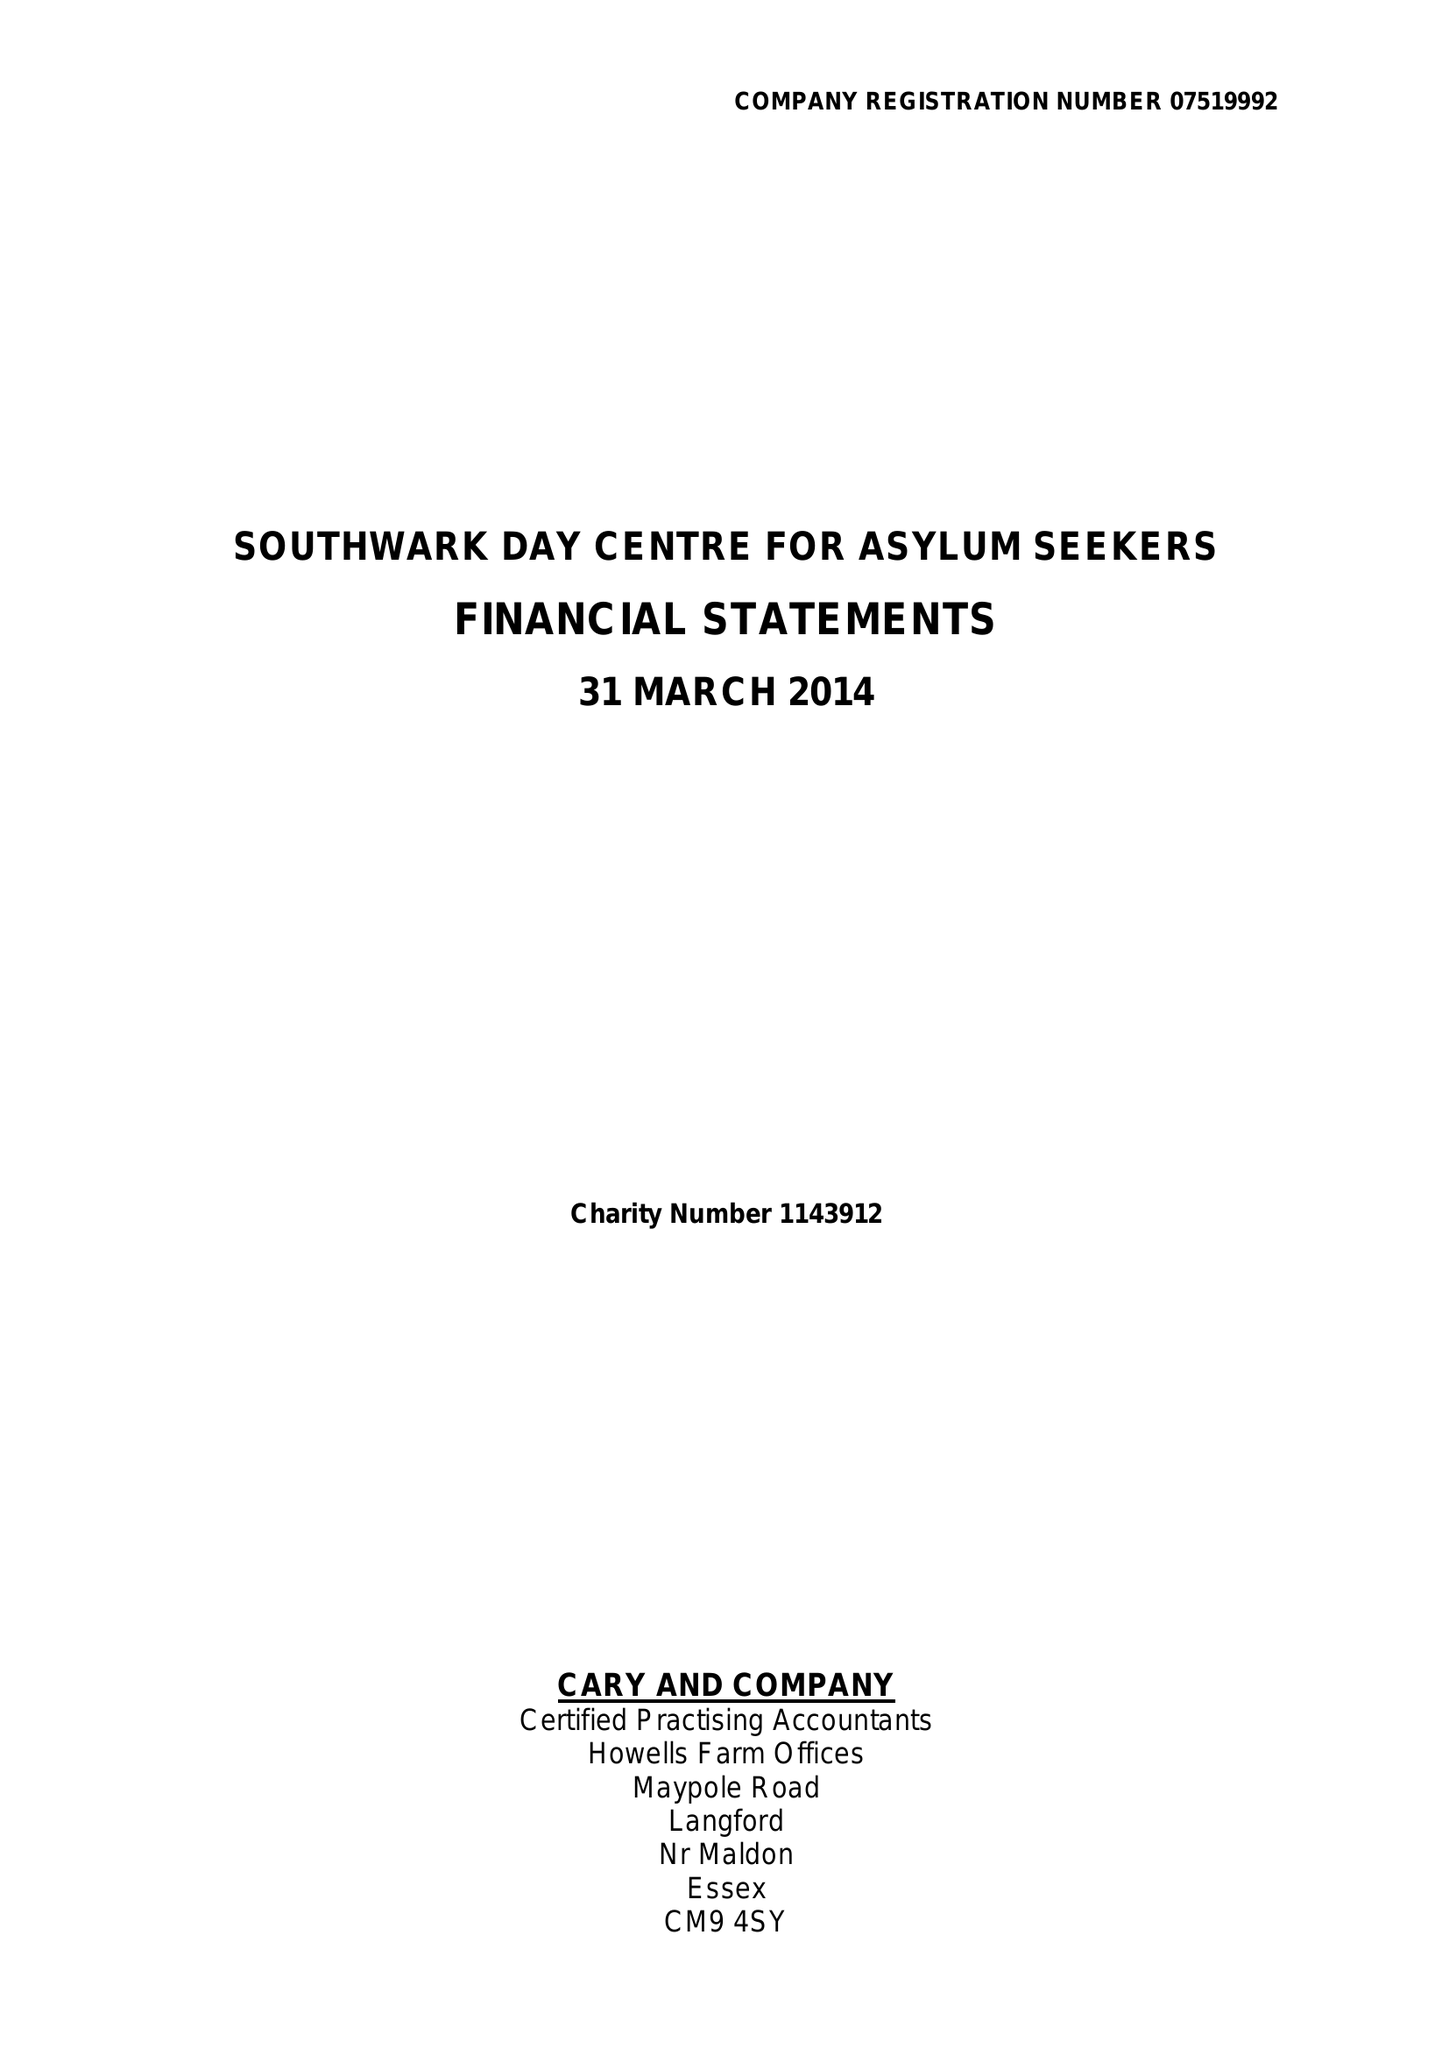What is the value for the income_annually_in_british_pounds?
Answer the question using a single word or phrase. 204476.00 